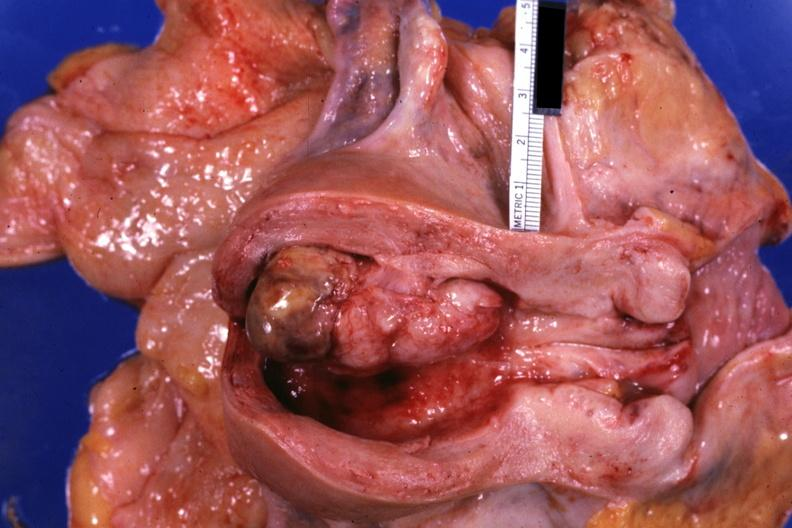what does this image show?
Answer the question using a single word or phrase. Opened uterus with polypoid lesion 